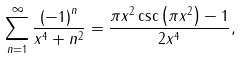<formula> <loc_0><loc_0><loc_500><loc_500>\sum _ { n = 1 } ^ { \infty } \frac { \left ( - 1 \right ) ^ { n } } { x ^ { 4 } + n ^ { 2 } } = \frac { \pi x ^ { 2 } \csc \left ( \pi x ^ { 2 } \right ) - 1 } { 2 x ^ { 4 } } ,</formula> 